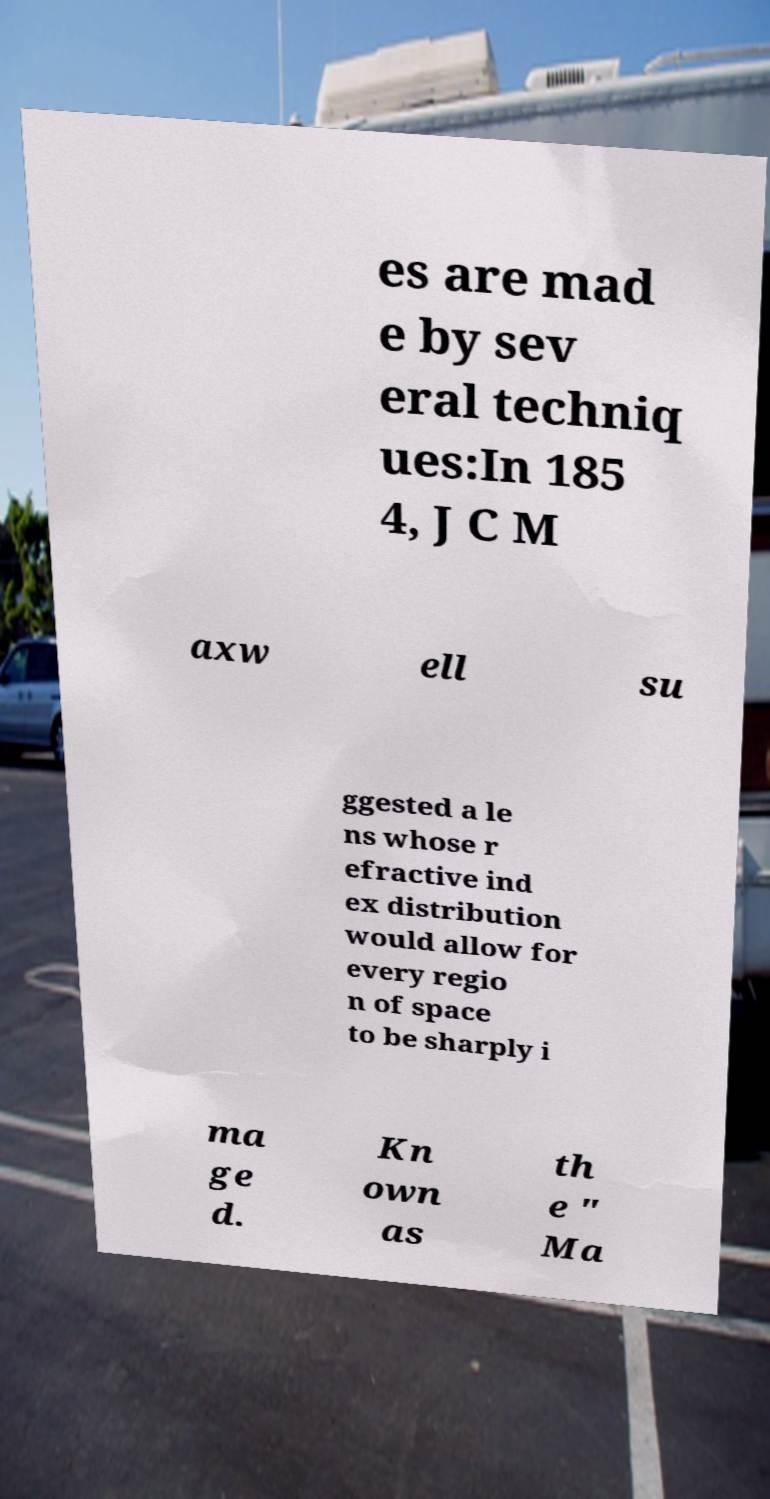Can you read and provide the text displayed in the image?This photo seems to have some interesting text. Can you extract and type it out for me? es are mad e by sev eral techniq ues:In 185 4, J C M axw ell su ggested a le ns whose r efractive ind ex distribution would allow for every regio n of space to be sharply i ma ge d. Kn own as th e " Ma 